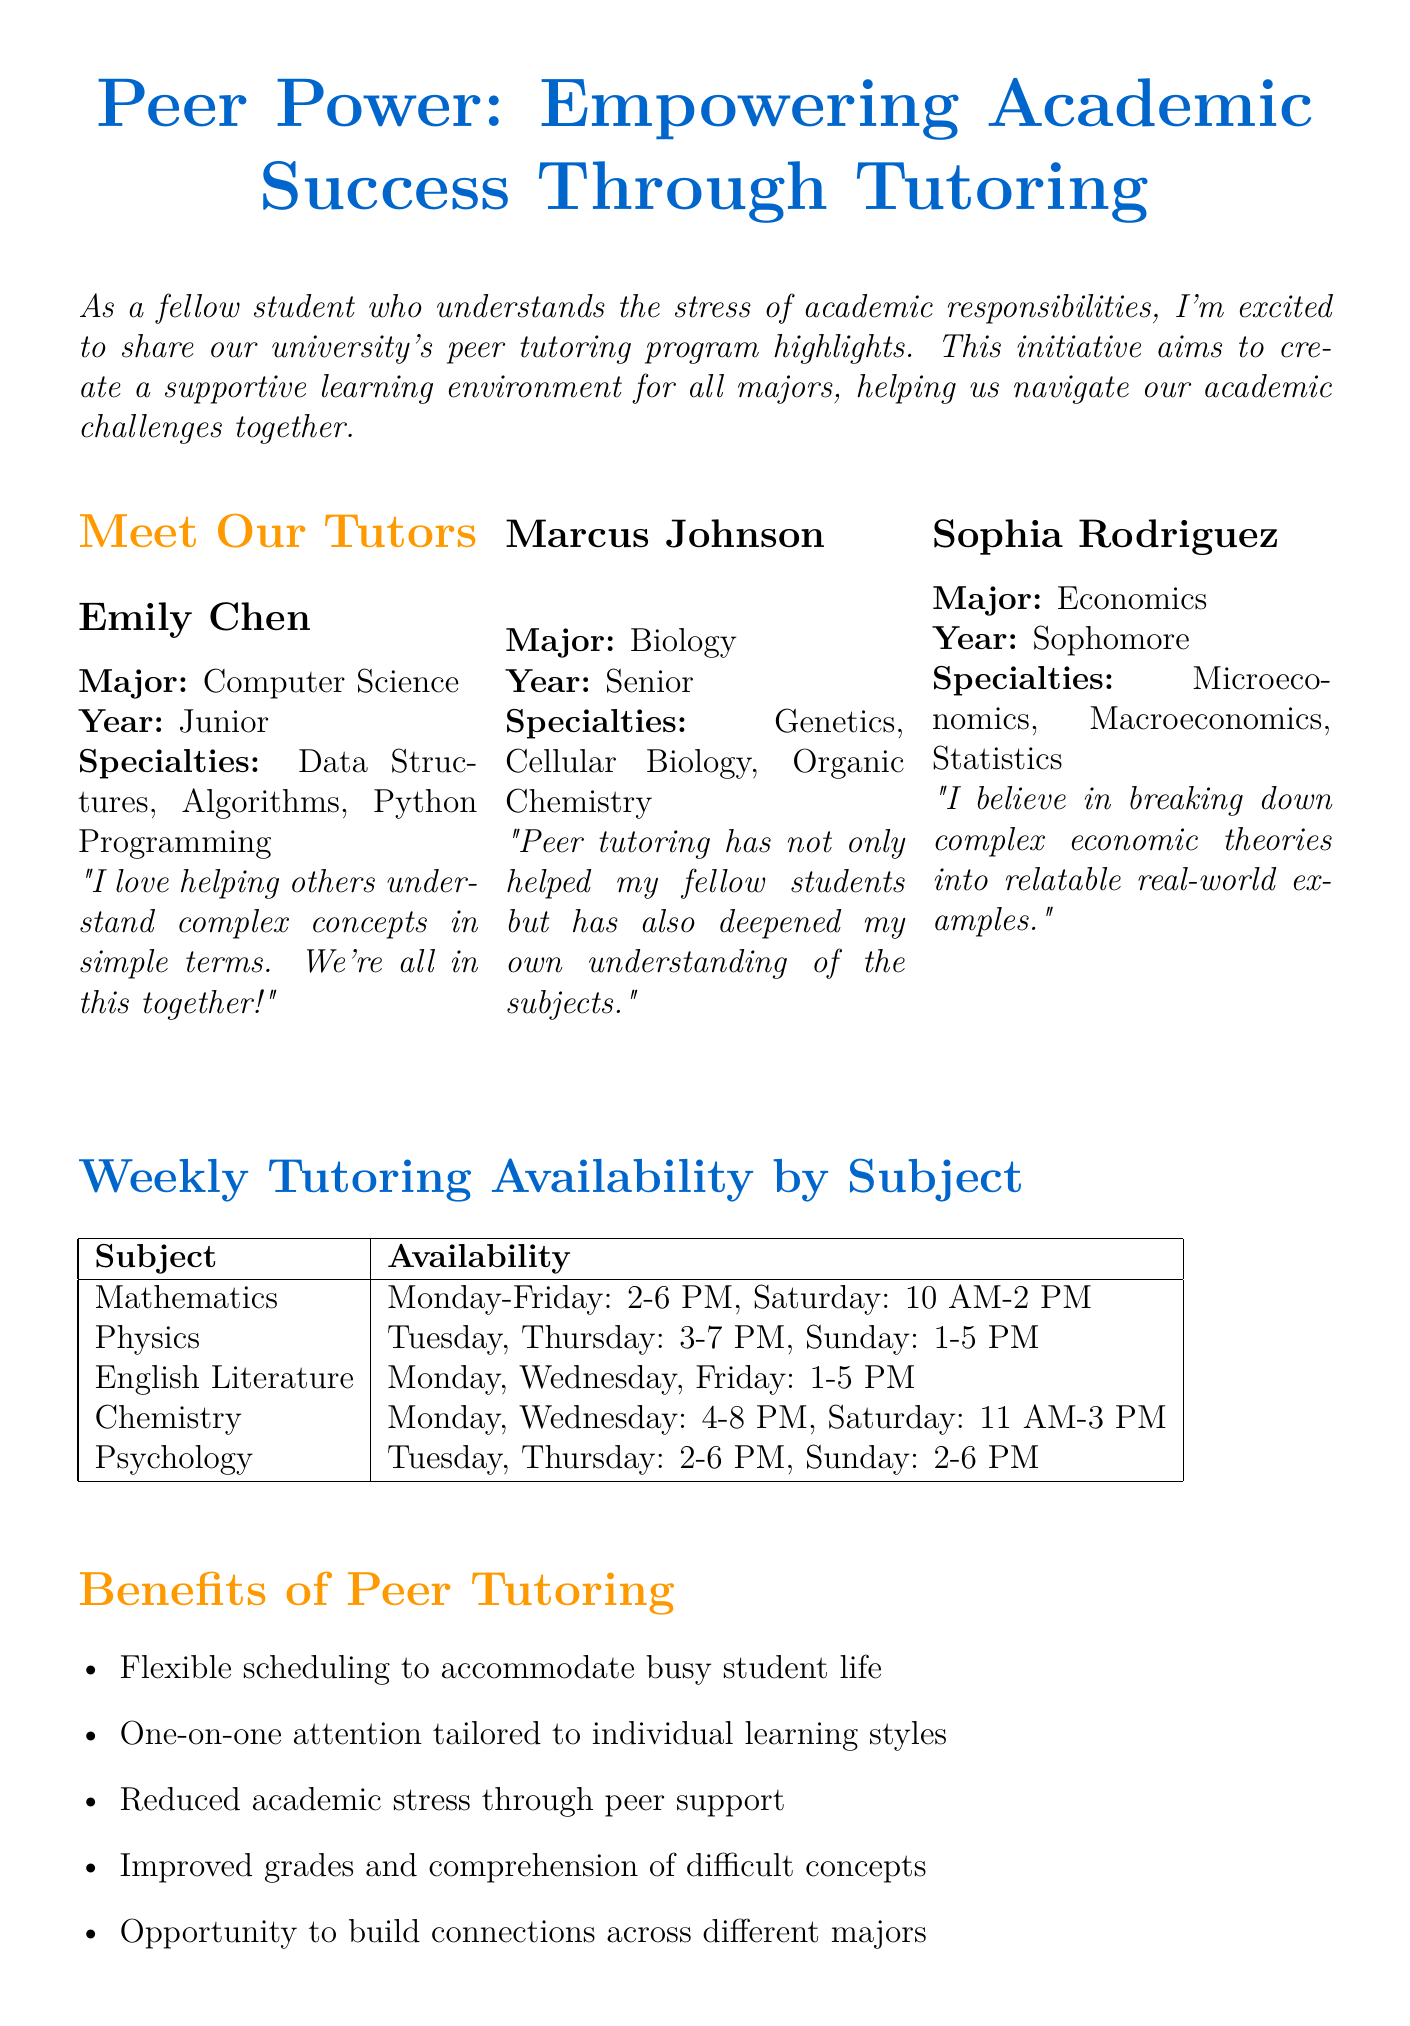What is the title of the newsletter? The title of the newsletter is clearly stated at the beginning, highlighting the focus on peer tutoring.
Answer: Peer Power: Empowering Academic Success Through Tutoring Who is the tutor majoring in Economics? The tutor profiles provide specific information about each tutor, including their major.
Answer: Sophia Rodriguez What day is the Tutor Meet & Greet event scheduled? The upcoming events section details the date for each listed event, with a focus on the Tutor Meet & Greet.
Answer: September 15, 2023 How many subjects are listed in the Weekly Tutoring Availability by Subject? The subject availability chart contains a list of subjects, and counting them gives the total number.
Answer: 5 What quote is associated with Marcus Johnson? Each tutor's profile includes a personal quote, and the question asks for Marcus Johnson's specific quote.
Answer: "Peer tutoring has not only helped my fellow students but has also deepened my own understanding of the subjects." What is one benefit of the peer tutoring program? The list of benefits highlights specific advantages of participating in the program.
Answer: Flexible scheduling to accommodate busy student life On which days is Psychology tutoring available? The subject availability chart specifies the days for each subject's tutoring sessions, including Psychology.
Answer: Tuesday, Thursday, Sunday 